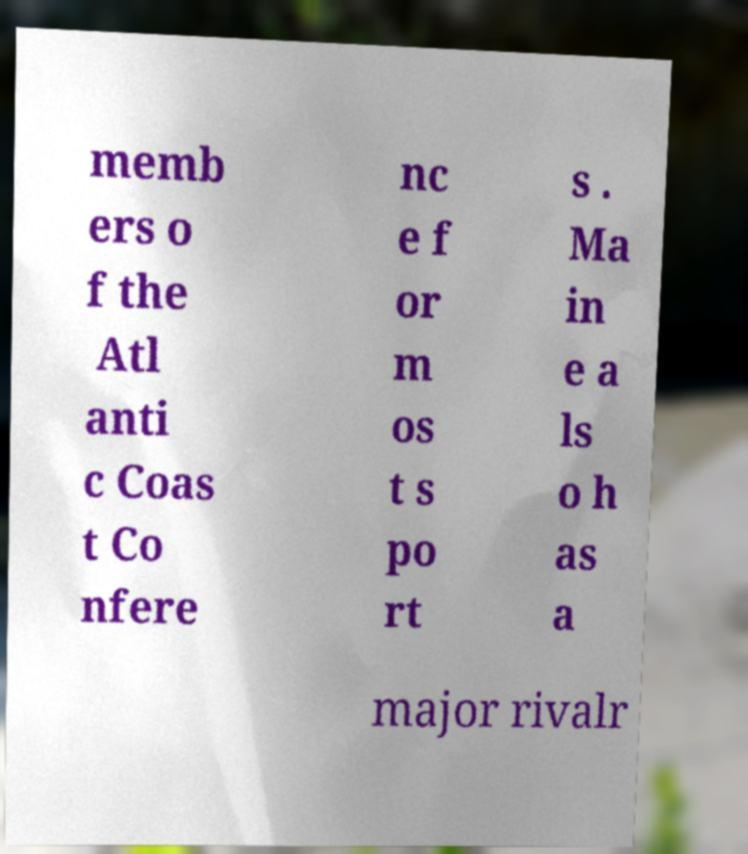Can you read and provide the text displayed in the image?This photo seems to have some interesting text. Can you extract and type it out for me? memb ers o f the Atl anti c Coas t Co nfere nc e f or m os t s po rt s . Ma in e a ls o h as a major rivalr 